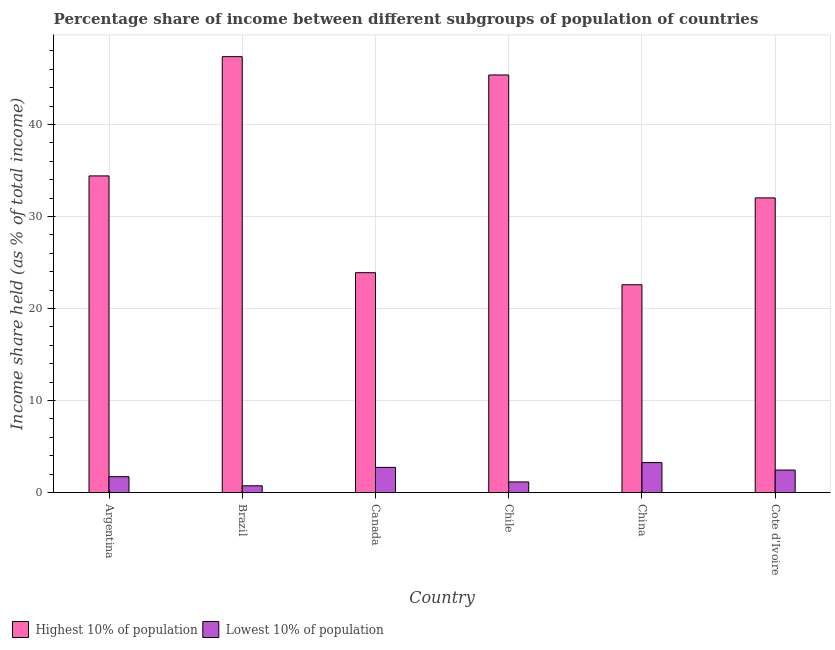How many groups of bars are there?
Offer a terse response. 6. Are the number of bars per tick equal to the number of legend labels?
Your answer should be compact. Yes. What is the label of the 1st group of bars from the left?
Keep it short and to the point. Argentina. What is the income share held by highest 10% of the population in China?
Offer a terse response. 22.59. Across all countries, what is the maximum income share held by highest 10% of the population?
Offer a very short reply. 47.38. Across all countries, what is the minimum income share held by lowest 10% of the population?
Keep it short and to the point. 0.74. In which country was the income share held by lowest 10% of the population maximum?
Your answer should be compact. China. In which country was the income share held by highest 10% of the population minimum?
Ensure brevity in your answer.  China. What is the total income share held by highest 10% of the population in the graph?
Offer a very short reply. 205.71. What is the difference between the income share held by highest 10% of the population in Brazil and that in Chile?
Make the answer very short. 1.99. What is the difference between the income share held by highest 10% of the population in China and the income share held by lowest 10% of the population in Brazil?
Offer a terse response. 21.85. What is the average income share held by highest 10% of the population per country?
Provide a succinct answer. 34.29. What is the difference between the income share held by highest 10% of the population and income share held by lowest 10% of the population in Chile?
Ensure brevity in your answer.  44.23. What is the ratio of the income share held by highest 10% of the population in Argentina to that in Brazil?
Give a very brief answer. 0.73. What is the difference between the highest and the second highest income share held by highest 10% of the population?
Provide a succinct answer. 1.99. What is the difference between the highest and the lowest income share held by lowest 10% of the population?
Offer a very short reply. 2.52. In how many countries, is the income share held by highest 10% of the population greater than the average income share held by highest 10% of the population taken over all countries?
Your answer should be compact. 3. What does the 2nd bar from the left in Chile represents?
Ensure brevity in your answer.  Lowest 10% of population. What does the 2nd bar from the right in China represents?
Keep it short and to the point. Highest 10% of population. How many countries are there in the graph?
Keep it short and to the point. 6. Does the graph contain any zero values?
Provide a short and direct response. No. What is the title of the graph?
Provide a succinct answer. Percentage share of income between different subgroups of population of countries. Does "Methane" appear as one of the legend labels in the graph?
Offer a terse response. No. What is the label or title of the Y-axis?
Keep it short and to the point. Income share held (as % of total income). What is the Income share held (as % of total income) in Highest 10% of population in Argentina?
Offer a terse response. 34.42. What is the Income share held (as % of total income) of Lowest 10% of population in Argentina?
Offer a terse response. 1.73. What is the Income share held (as % of total income) of Highest 10% of population in Brazil?
Offer a very short reply. 47.38. What is the Income share held (as % of total income) in Lowest 10% of population in Brazil?
Give a very brief answer. 0.74. What is the Income share held (as % of total income) of Highest 10% of population in Canada?
Ensure brevity in your answer.  23.9. What is the Income share held (as % of total income) of Lowest 10% of population in Canada?
Keep it short and to the point. 2.74. What is the Income share held (as % of total income) in Highest 10% of population in Chile?
Your answer should be very brief. 45.39. What is the Income share held (as % of total income) of Lowest 10% of population in Chile?
Keep it short and to the point. 1.16. What is the Income share held (as % of total income) of Highest 10% of population in China?
Offer a terse response. 22.59. What is the Income share held (as % of total income) in Lowest 10% of population in China?
Offer a terse response. 3.26. What is the Income share held (as % of total income) of Highest 10% of population in Cote d'Ivoire?
Give a very brief answer. 32.03. What is the Income share held (as % of total income) in Lowest 10% of population in Cote d'Ivoire?
Your answer should be compact. 2.45. Across all countries, what is the maximum Income share held (as % of total income) of Highest 10% of population?
Your answer should be compact. 47.38. Across all countries, what is the maximum Income share held (as % of total income) of Lowest 10% of population?
Offer a terse response. 3.26. Across all countries, what is the minimum Income share held (as % of total income) of Highest 10% of population?
Keep it short and to the point. 22.59. Across all countries, what is the minimum Income share held (as % of total income) of Lowest 10% of population?
Your answer should be very brief. 0.74. What is the total Income share held (as % of total income) in Highest 10% of population in the graph?
Ensure brevity in your answer.  205.71. What is the total Income share held (as % of total income) of Lowest 10% of population in the graph?
Offer a very short reply. 12.08. What is the difference between the Income share held (as % of total income) of Highest 10% of population in Argentina and that in Brazil?
Provide a succinct answer. -12.96. What is the difference between the Income share held (as % of total income) of Highest 10% of population in Argentina and that in Canada?
Keep it short and to the point. 10.52. What is the difference between the Income share held (as % of total income) of Lowest 10% of population in Argentina and that in Canada?
Your answer should be compact. -1.01. What is the difference between the Income share held (as % of total income) in Highest 10% of population in Argentina and that in Chile?
Your response must be concise. -10.97. What is the difference between the Income share held (as % of total income) in Lowest 10% of population in Argentina and that in Chile?
Your answer should be very brief. 0.57. What is the difference between the Income share held (as % of total income) in Highest 10% of population in Argentina and that in China?
Your answer should be compact. 11.83. What is the difference between the Income share held (as % of total income) in Lowest 10% of population in Argentina and that in China?
Your answer should be very brief. -1.53. What is the difference between the Income share held (as % of total income) in Highest 10% of population in Argentina and that in Cote d'Ivoire?
Your answer should be compact. 2.39. What is the difference between the Income share held (as % of total income) in Lowest 10% of population in Argentina and that in Cote d'Ivoire?
Ensure brevity in your answer.  -0.72. What is the difference between the Income share held (as % of total income) in Highest 10% of population in Brazil and that in Canada?
Ensure brevity in your answer.  23.48. What is the difference between the Income share held (as % of total income) in Lowest 10% of population in Brazil and that in Canada?
Your answer should be compact. -2. What is the difference between the Income share held (as % of total income) of Highest 10% of population in Brazil and that in Chile?
Offer a terse response. 1.99. What is the difference between the Income share held (as % of total income) in Lowest 10% of population in Brazil and that in Chile?
Offer a very short reply. -0.42. What is the difference between the Income share held (as % of total income) in Highest 10% of population in Brazil and that in China?
Provide a short and direct response. 24.79. What is the difference between the Income share held (as % of total income) of Lowest 10% of population in Brazil and that in China?
Ensure brevity in your answer.  -2.52. What is the difference between the Income share held (as % of total income) in Highest 10% of population in Brazil and that in Cote d'Ivoire?
Keep it short and to the point. 15.35. What is the difference between the Income share held (as % of total income) of Lowest 10% of population in Brazil and that in Cote d'Ivoire?
Ensure brevity in your answer.  -1.71. What is the difference between the Income share held (as % of total income) in Highest 10% of population in Canada and that in Chile?
Your answer should be compact. -21.49. What is the difference between the Income share held (as % of total income) of Lowest 10% of population in Canada and that in Chile?
Provide a succinct answer. 1.58. What is the difference between the Income share held (as % of total income) of Highest 10% of population in Canada and that in China?
Provide a succinct answer. 1.31. What is the difference between the Income share held (as % of total income) in Lowest 10% of population in Canada and that in China?
Keep it short and to the point. -0.52. What is the difference between the Income share held (as % of total income) of Highest 10% of population in Canada and that in Cote d'Ivoire?
Keep it short and to the point. -8.13. What is the difference between the Income share held (as % of total income) of Lowest 10% of population in Canada and that in Cote d'Ivoire?
Offer a very short reply. 0.29. What is the difference between the Income share held (as % of total income) of Highest 10% of population in Chile and that in China?
Your answer should be very brief. 22.8. What is the difference between the Income share held (as % of total income) in Highest 10% of population in Chile and that in Cote d'Ivoire?
Keep it short and to the point. 13.36. What is the difference between the Income share held (as % of total income) in Lowest 10% of population in Chile and that in Cote d'Ivoire?
Your answer should be compact. -1.29. What is the difference between the Income share held (as % of total income) of Highest 10% of population in China and that in Cote d'Ivoire?
Make the answer very short. -9.44. What is the difference between the Income share held (as % of total income) in Lowest 10% of population in China and that in Cote d'Ivoire?
Your answer should be compact. 0.81. What is the difference between the Income share held (as % of total income) of Highest 10% of population in Argentina and the Income share held (as % of total income) of Lowest 10% of population in Brazil?
Keep it short and to the point. 33.68. What is the difference between the Income share held (as % of total income) in Highest 10% of population in Argentina and the Income share held (as % of total income) in Lowest 10% of population in Canada?
Give a very brief answer. 31.68. What is the difference between the Income share held (as % of total income) of Highest 10% of population in Argentina and the Income share held (as % of total income) of Lowest 10% of population in Chile?
Offer a terse response. 33.26. What is the difference between the Income share held (as % of total income) in Highest 10% of population in Argentina and the Income share held (as % of total income) in Lowest 10% of population in China?
Provide a succinct answer. 31.16. What is the difference between the Income share held (as % of total income) of Highest 10% of population in Argentina and the Income share held (as % of total income) of Lowest 10% of population in Cote d'Ivoire?
Give a very brief answer. 31.97. What is the difference between the Income share held (as % of total income) of Highest 10% of population in Brazil and the Income share held (as % of total income) of Lowest 10% of population in Canada?
Offer a very short reply. 44.64. What is the difference between the Income share held (as % of total income) in Highest 10% of population in Brazil and the Income share held (as % of total income) in Lowest 10% of population in Chile?
Offer a terse response. 46.22. What is the difference between the Income share held (as % of total income) of Highest 10% of population in Brazil and the Income share held (as % of total income) of Lowest 10% of population in China?
Offer a very short reply. 44.12. What is the difference between the Income share held (as % of total income) of Highest 10% of population in Brazil and the Income share held (as % of total income) of Lowest 10% of population in Cote d'Ivoire?
Give a very brief answer. 44.93. What is the difference between the Income share held (as % of total income) of Highest 10% of population in Canada and the Income share held (as % of total income) of Lowest 10% of population in Chile?
Ensure brevity in your answer.  22.74. What is the difference between the Income share held (as % of total income) in Highest 10% of population in Canada and the Income share held (as % of total income) in Lowest 10% of population in China?
Provide a succinct answer. 20.64. What is the difference between the Income share held (as % of total income) of Highest 10% of population in Canada and the Income share held (as % of total income) of Lowest 10% of population in Cote d'Ivoire?
Your answer should be compact. 21.45. What is the difference between the Income share held (as % of total income) in Highest 10% of population in Chile and the Income share held (as % of total income) in Lowest 10% of population in China?
Offer a terse response. 42.13. What is the difference between the Income share held (as % of total income) in Highest 10% of population in Chile and the Income share held (as % of total income) in Lowest 10% of population in Cote d'Ivoire?
Give a very brief answer. 42.94. What is the difference between the Income share held (as % of total income) of Highest 10% of population in China and the Income share held (as % of total income) of Lowest 10% of population in Cote d'Ivoire?
Ensure brevity in your answer.  20.14. What is the average Income share held (as % of total income) in Highest 10% of population per country?
Ensure brevity in your answer.  34.28. What is the average Income share held (as % of total income) of Lowest 10% of population per country?
Keep it short and to the point. 2.01. What is the difference between the Income share held (as % of total income) of Highest 10% of population and Income share held (as % of total income) of Lowest 10% of population in Argentina?
Offer a terse response. 32.69. What is the difference between the Income share held (as % of total income) in Highest 10% of population and Income share held (as % of total income) in Lowest 10% of population in Brazil?
Keep it short and to the point. 46.64. What is the difference between the Income share held (as % of total income) of Highest 10% of population and Income share held (as % of total income) of Lowest 10% of population in Canada?
Provide a succinct answer. 21.16. What is the difference between the Income share held (as % of total income) in Highest 10% of population and Income share held (as % of total income) in Lowest 10% of population in Chile?
Your answer should be very brief. 44.23. What is the difference between the Income share held (as % of total income) of Highest 10% of population and Income share held (as % of total income) of Lowest 10% of population in China?
Give a very brief answer. 19.33. What is the difference between the Income share held (as % of total income) in Highest 10% of population and Income share held (as % of total income) in Lowest 10% of population in Cote d'Ivoire?
Provide a short and direct response. 29.58. What is the ratio of the Income share held (as % of total income) in Highest 10% of population in Argentina to that in Brazil?
Provide a short and direct response. 0.73. What is the ratio of the Income share held (as % of total income) in Lowest 10% of population in Argentina to that in Brazil?
Give a very brief answer. 2.34. What is the ratio of the Income share held (as % of total income) of Highest 10% of population in Argentina to that in Canada?
Make the answer very short. 1.44. What is the ratio of the Income share held (as % of total income) in Lowest 10% of population in Argentina to that in Canada?
Your answer should be very brief. 0.63. What is the ratio of the Income share held (as % of total income) of Highest 10% of population in Argentina to that in Chile?
Ensure brevity in your answer.  0.76. What is the ratio of the Income share held (as % of total income) of Lowest 10% of population in Argentina to that in Chile?
Your answer should be very brief. 1.49. What is the ratio of the Income share held (as % of total income) of Highest 10% of population in Argentina to that in China?
Your answer should be very brief. 1.52. What is the ratio of the Income share held (as % of total income) in Lowest 10% of population in Argentina to that in China?
Provide a short and direct response. 0.53. What is the ratio of the Income share held (as % of total income) in Highest 10% of population in Argentina to that in Cote d'Ivoire?
Ensure brevity in your answer.  1.07. What is the ratio of the Income share held (as % of total income) of Lowest 10% of population in Argentina to that in Cote d'Ivoire?
Make the answer very short. 0.71. What is the ratio of the Income share held (as % of total income) in Highest 10% of population in Brazil to that in Canada?
Provide a succinct answer. 1.98. What is the ratio of the Income share held (as % of total income) in Lowest 10% of population in Brazil to that in Canada?
Keep it short and to the point. 0.27. What is the ratio of the Income share held (as % of total income) in Highest 10% of population in Brazil to that in Chile?
Your answer should be very brief. 1.04. What is the ratio of the Income share held (as % of total income) in Lowest 10% of population in Brazil to that in Chile?
Your answer should be compact. 0.64. What is the ratio of the Income share held (as % of total income) in Highest 10% of population in Brazil to that in China?
Offer a very short reply. 2.1. What is the ratio of the Income share held (as % of total income) in Lowest 10% of population in Brazil to that in China?
Your response must be concise. 0.23. What is the ratio of the Income share held (as % of total income) of Highest 10% of population in Brazil to that in Cote d'Ivoire?
Make the answer very short. 1.48. What is the ratio of the Income share held (as % of total income) of Lowest 10% of population in Brazil to that in Cote d'Ivoire?
Make the answer very short. 0.3. What is the ratio of the Income share held (as % of total income) of Highest 10% of population in Canada to that in Chile?
Your answer should be compact. 0.53. What is the ratio of the Income share held (as % of total income) in Lowest 10% of population in Canada to that in Chile?
Your answer should be compact. 2.36. What is the ratio of the Income share held (as % of total income) of Highest 10% of population in Canada to that in China?
Ensure brevity in your answer.  1.06. What is the ratio of the Income share held (as % of total income) in Lowest 10% of population in Canada to that in China?
Your answer should be very brief. 0.84. What is the ratio of the Income share held (as % of total income) in Highest 10% of population in Canada to that in Cote d'Ivoire?
Provide a short and direct response. 0.75. What is the ratio of the Income share held (as % of total income) of Lowest 10% of population in Canada to that in Cote d'Ivoire?
Offer a very short reply. 1.12. What is the ratio of the Income share held (as % of total income) of Highest 10% of population in Chile to that in China?
Give a very brief answer. 2.01. What is the ratio of the Income share held (as % of total income) in Lowest 10% of population in Chile to that in China?
Offer a terse response. 0.36. What is the ratio of the Income share held (as % of total income) of Highest 10% of population in Chile to that in Cote d'Ivoire?
Give a very brief answer. 1.42. What is the ratio of the Income share held (as % of total income) in Lowest 10% of population in Chile to that in Cote d'Ivoire?
Your response must be concise. 0.47. What is the ratio of the Income share held (as % of total income) of Highest 10% of population in China to that in Cote d'Ivoire?
Offer a terse response. 0.71. What is the ratio of the Income share held (as % of total income) of Lowest 10% of population in China to that in Cote d'Ivoire?
Ensure brevity in your answer.  1.33. What is the difference between the highest and the second highest Income share held (as % of total income) of Highest 10% of population?
Offer a terse response. 1.99. What is the difference between the highest and the second highest Income share held (as % of total income) in Lowest 10% of population?
Give a very brief answer. 0.52. What is the difference between the highest and the lowest Income share held (as % of total income) of Highest 10% of population?
Keep it short and to the point. 24.79. What is the difference between the highest and the lowest Income share held (as % of total income) in Lowest 10% of population?
Your response must be concise. 2.52. 